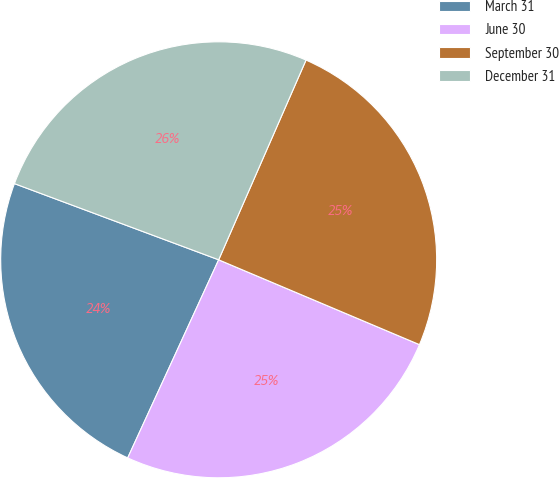<chart> <loc_0><loc_0><loc_500><loc_500><pie_chart><fcel>March 31<fcel>June 30<fcel>September 30<fcel>December 31<nl><fcel>23.83%<fcel>25.49%<fcel>24.8%<fcel>25.88%<nl></chart> 